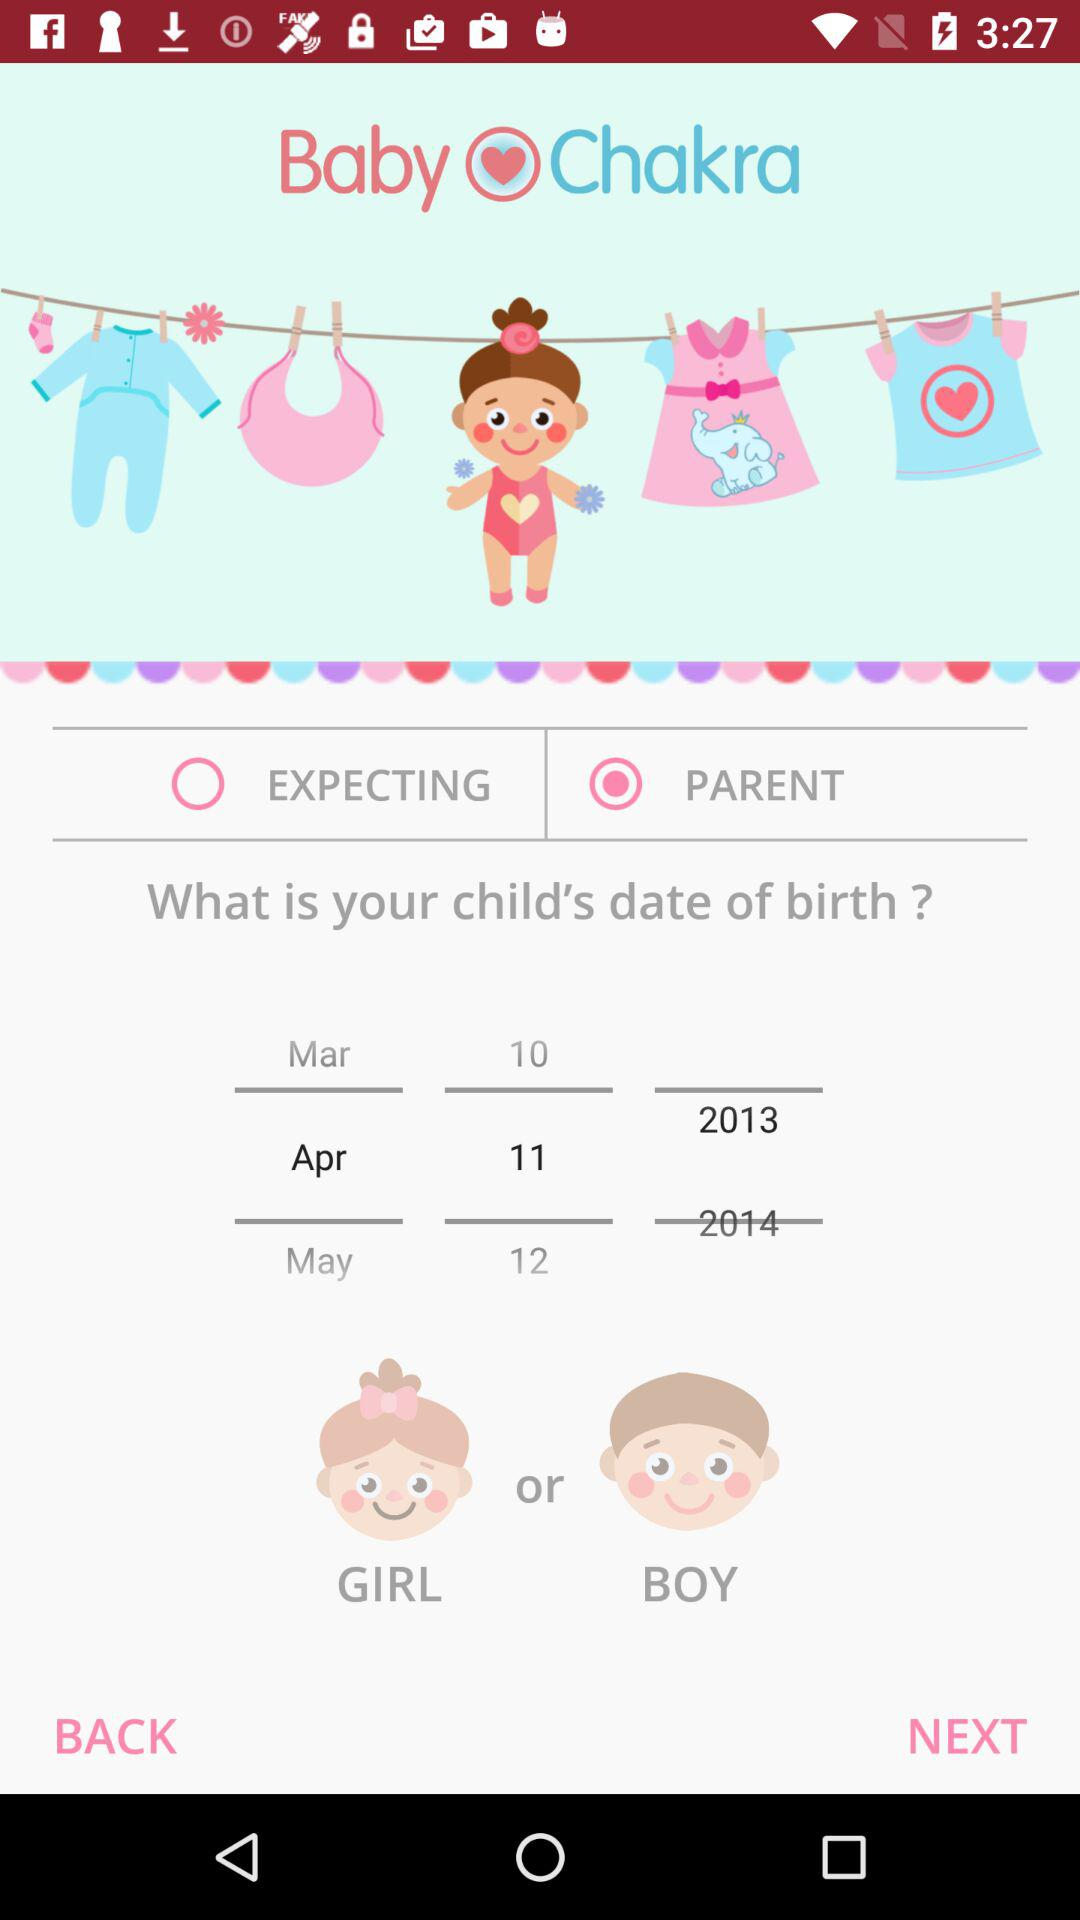What is the selected date? The selected date is April 11, 2013. 